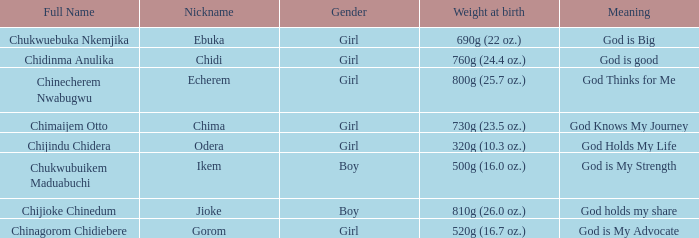5 oz.)? Chima. 